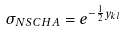<formula> <loc_0><loc_0><loc_500><loc_500>\sigma _ { N S C H A } = e ^ { - { \frac { 1 } { 2 } } y _ { k l } }</formula> 